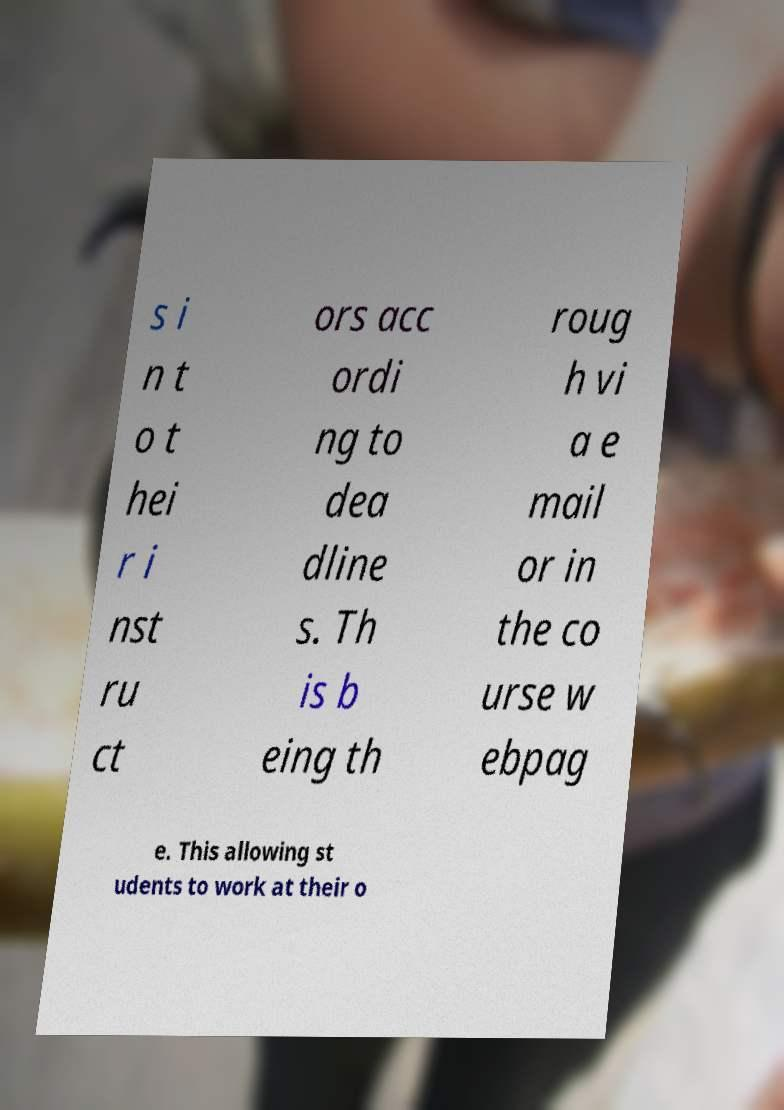Can you read and provide the text displayed in the image?This photo seems to have some interesting text. Can you extract and type it out for me? s i n t o t hei r i nst ru ct ors acc ordi ng to dea dline s. Th is b eing th roug h vi a e mail or in the co urse w ebpag e. This allowing st udents to work at their o 